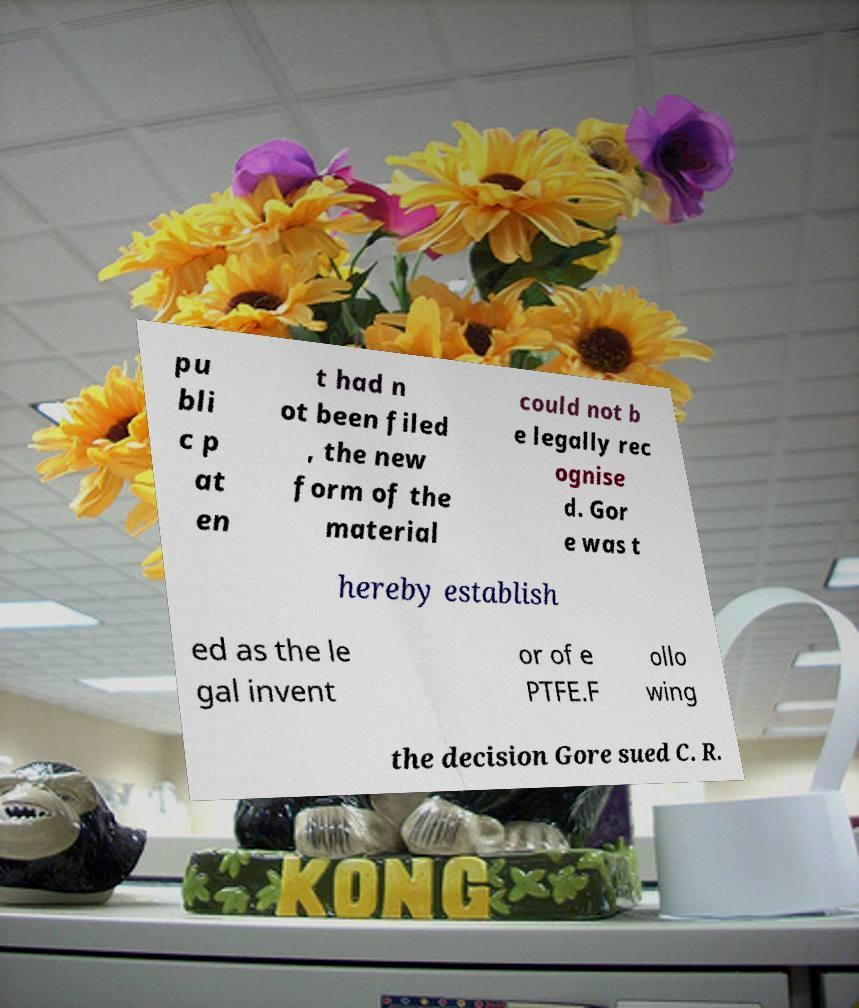Please read and relay the text visible in this image. What does it say? pu bli c p at en t had n ot been filed , the new form of the material could not b e legally rec ognise d. Gor e was t hereby establish ed as the le gal invent or of e PTFE.F ollo wing the decision Gore sued C. R. 